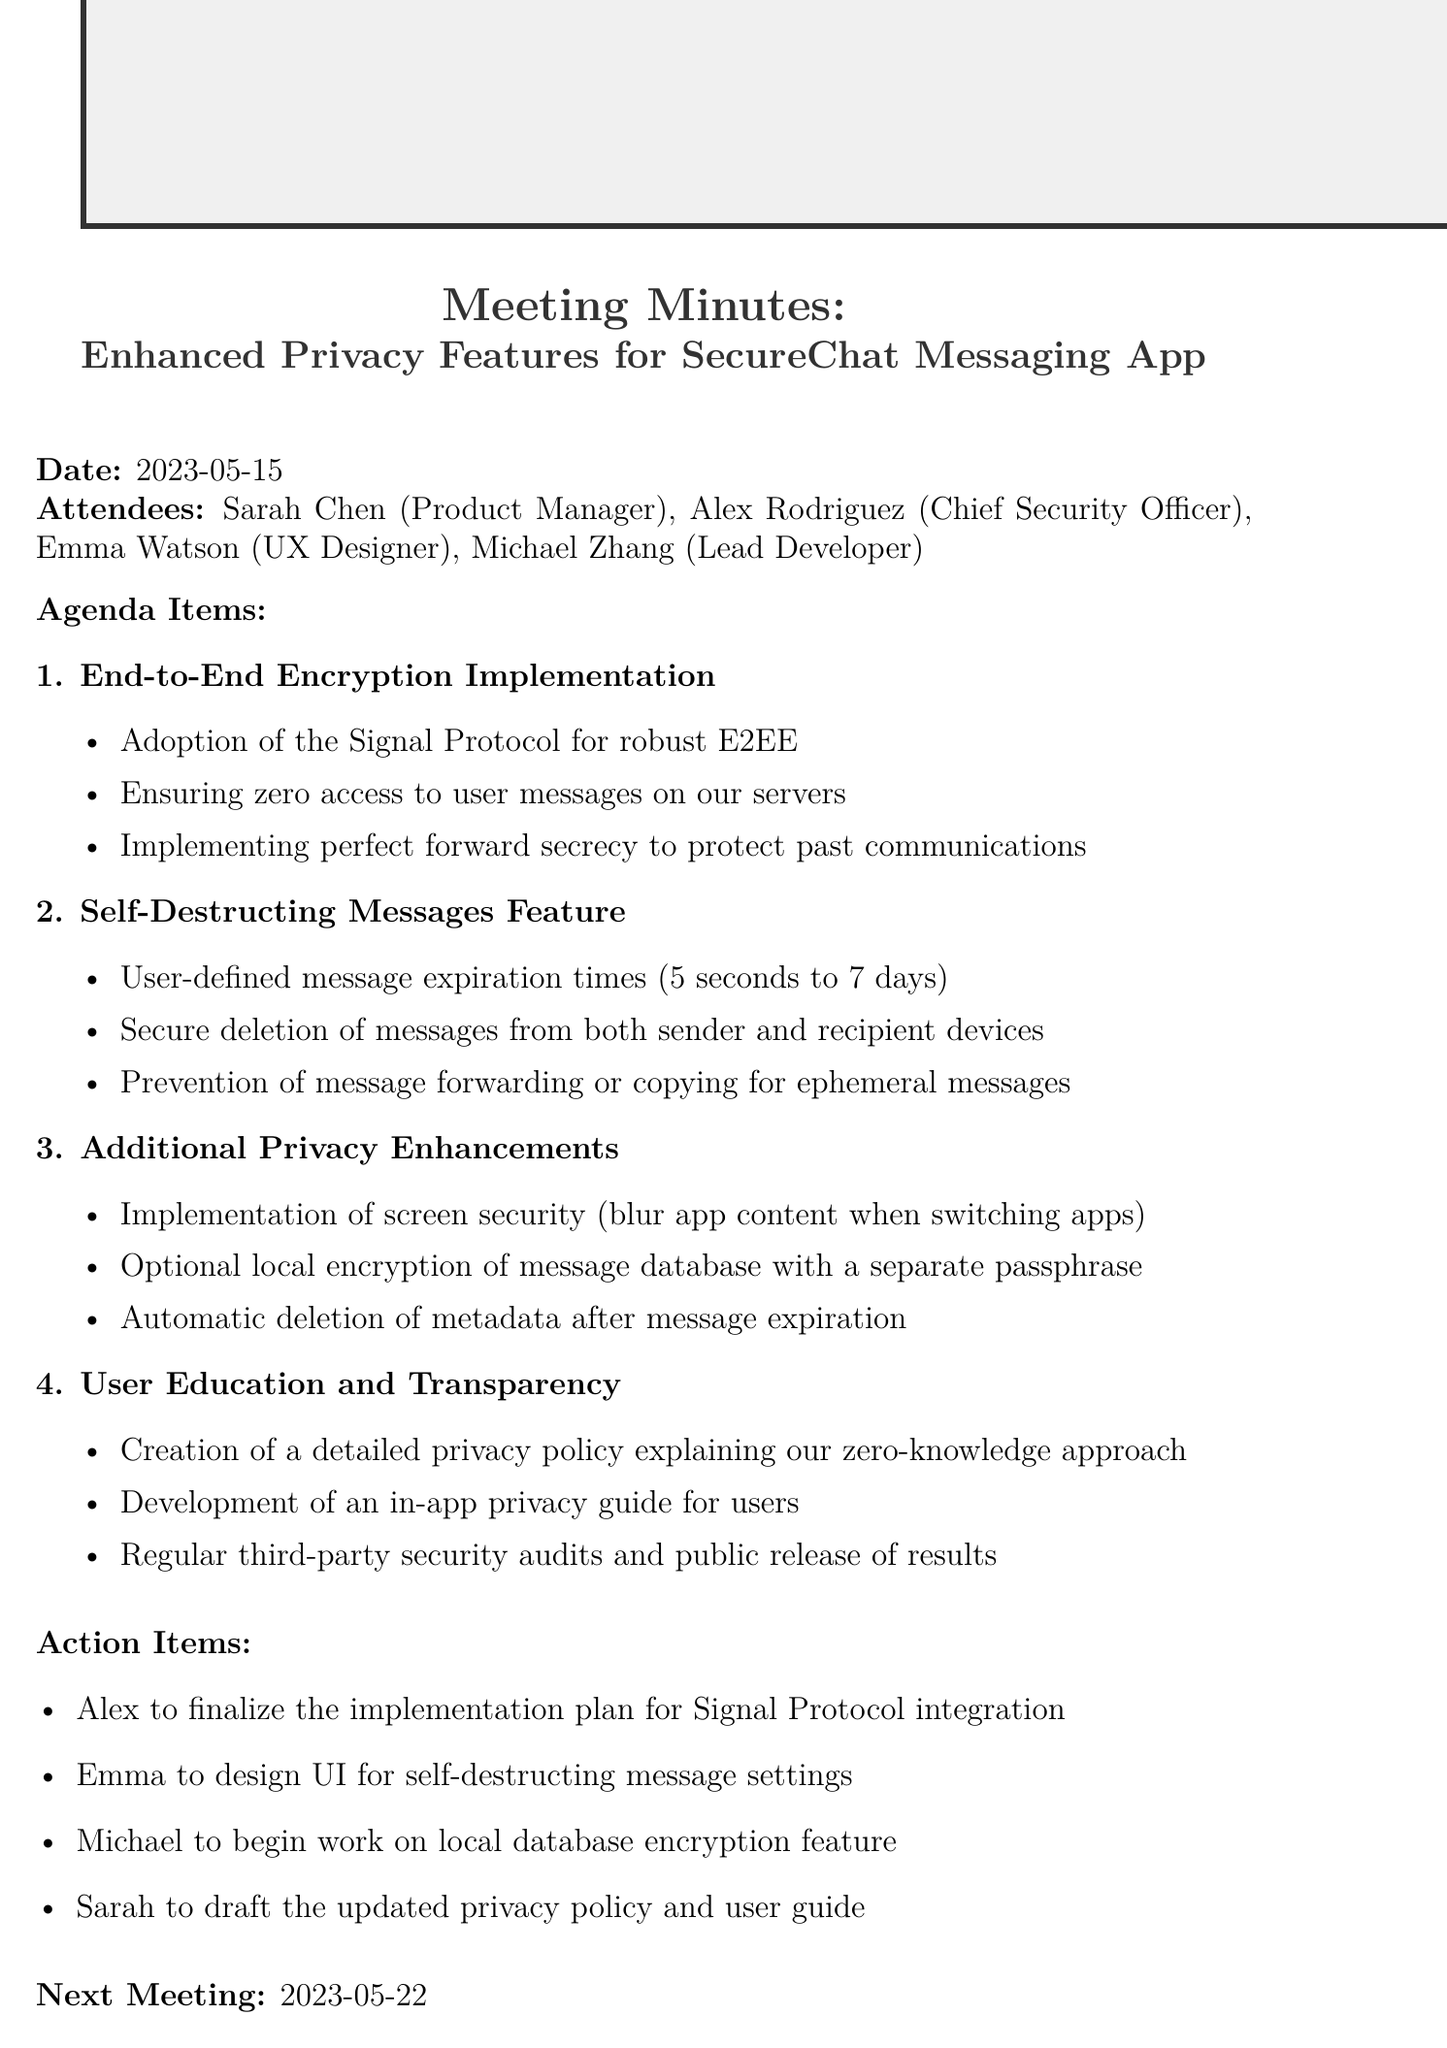What is the meeting date? The meeting date is specifically mentioned in the document, which is May 15, 2023.
Answer: May 15, 2023 Who is the Product Manager? The document lists attendees, identifying the Product Manager as Sarah Chen.
Answer: Sarah Chen What feature allows user-defined message expiration times? The discussion points outline the self-destructing messages feature which includes user-defined expiration times.
Answer: Self-Destructing Messages Feature What is the main protocol adopted for end-to-end encryption? The document specifies the adoption of the Signal Protocol for robust end-to-end encryption implementation.
Answer: Signal Protocol What action item is assigned to Emma? The action items list specifies that Emma is to design the UI for self-destructing message settings.
Answer: Design UI for self-destructing message settings What additional privacy enhancement involves local encryption? The document mentions the implementation of optional local encryption of message database with a separate passphrase.
Answer: Optional local encryption of message database When is the next meeting scheduled? The document clearly states that the next meeting is scheduled for May 22, 2023.
Answer: May 22, 2023 How many attendees were present in the meeting? The attendees section lists four individuals present at the meeting.
Answer: Four What does the privacy policy aim to explain? The document states that the privacy policy aims to explain the zero-knowledge approach taken by the messaging app.
Answer: Zero-knowledge approach 